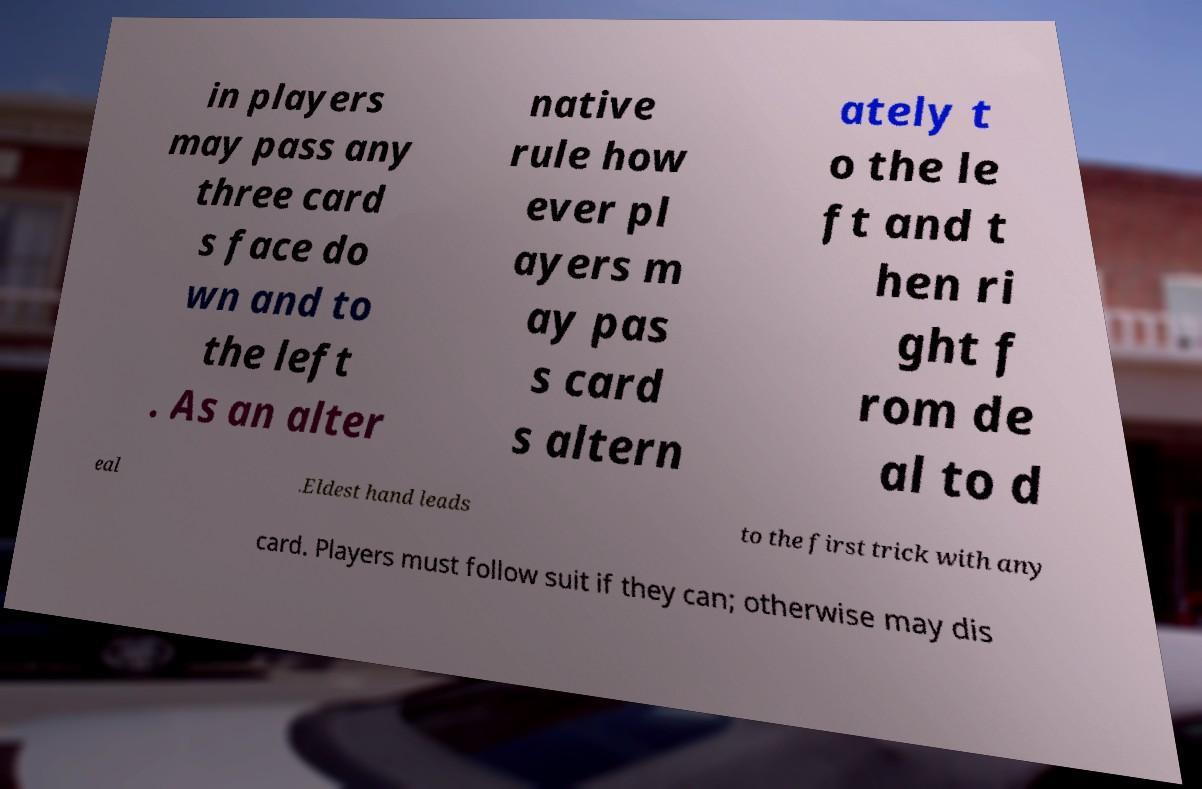What messages or text are displayed in this image? I need them in a readable, typed format. in players may pass any three card s face do wn and to the left . As an alter native rule how ever pl ayers m ay pas s card s altern ately t o the le ft and t hen ri ght f rom de al to d eal .Eldest hand leads to the first trick with any card. Players must follow suit if they can; otherwise may dis 